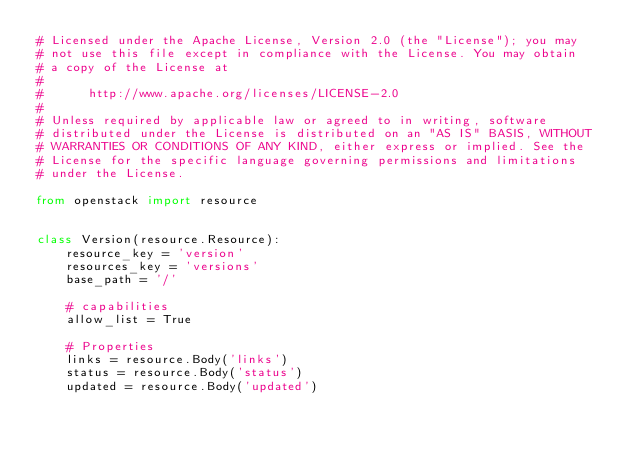<code> <loc_0><loc_0><loc_500><loc_500><_Python_># Licensed under the Apache License, Version 2.0 (the "License"); you may
# not use this file except in compliance with the License. You may obtain
# a copy of the License at
#
#      http://www.apache.org/licenses/LICENSE-2.0
#
# Unless required by applicable law or agreed to in writing, software
# distributed under the License is distributed on an "AS IS" BASIS, WITHOUT
# WARRANTIES OR CONDITIONS OF ANY KIND, either express or implied. See the
# License for the specific language governing permissions and limitations
# under the License.

from openstack import resource


class Version(resource.Resource):
    resource_key = 'version'
    resources_key = 'versions'
    base_path = '/'

    # capabilities
    allow_list = True

    # Properties
    links = resource.Body('links')
    status = resource.Body('status')
    updated = resource.Body('updated')
</code> 